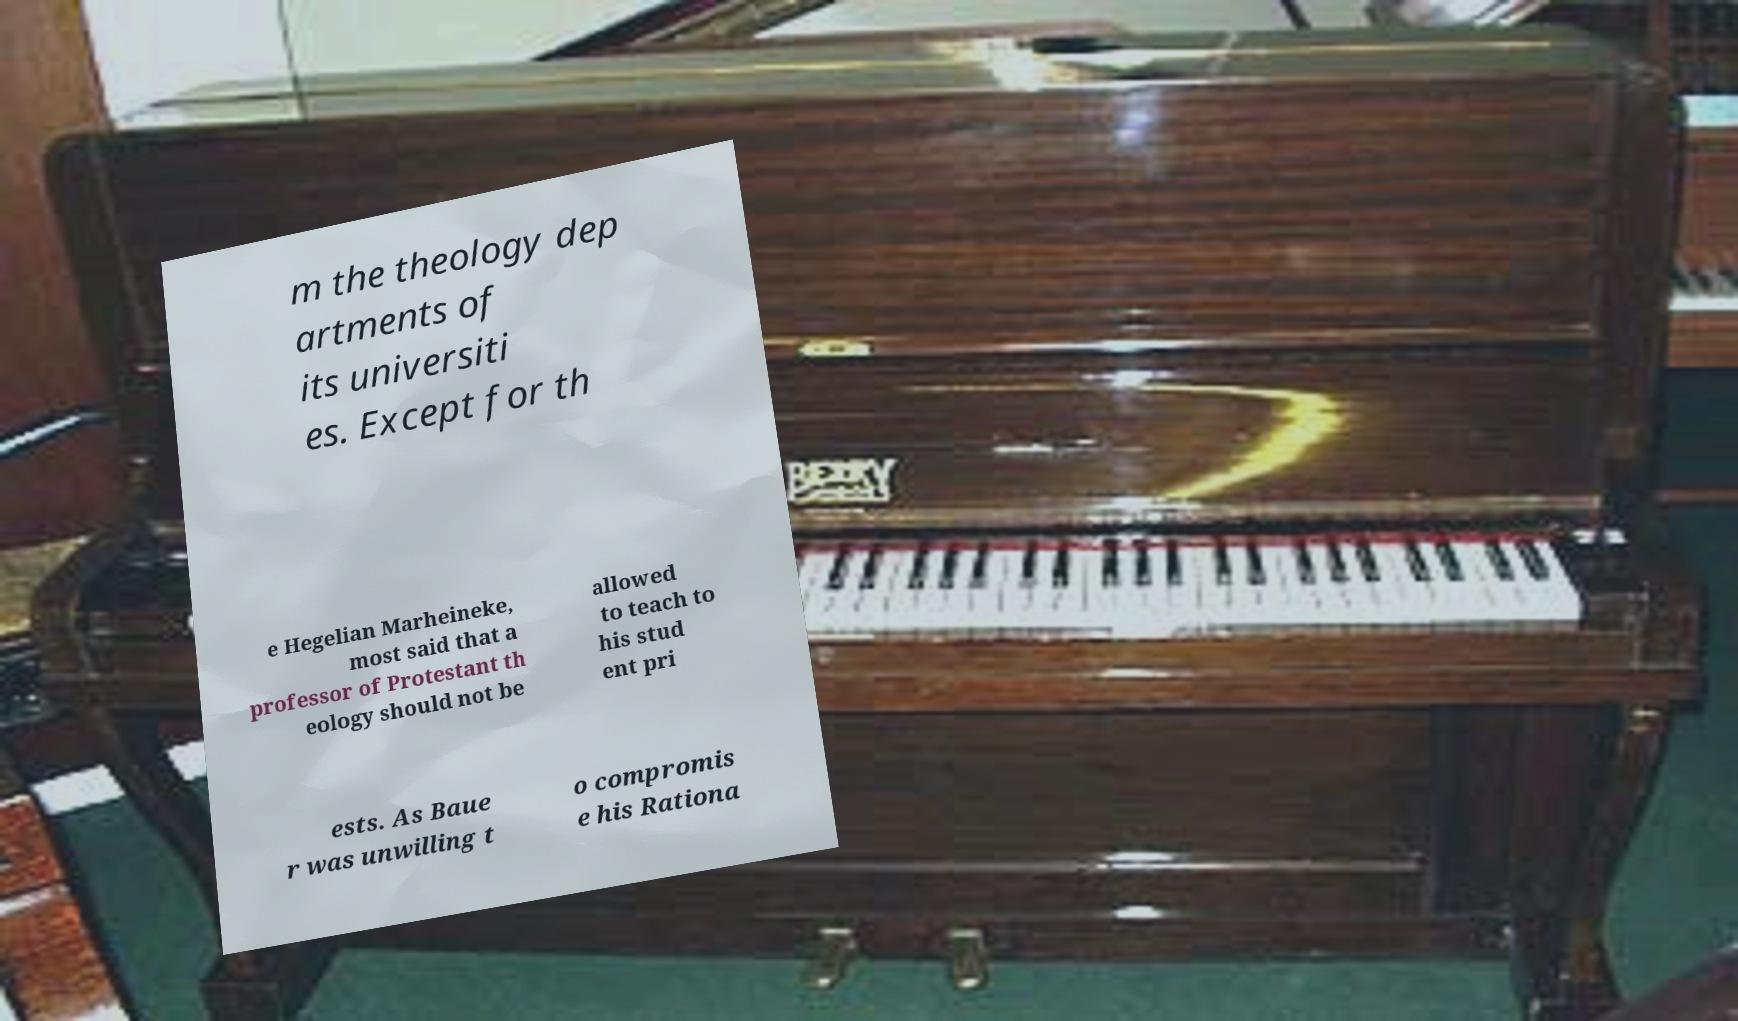Please identify and transcribe the text found in this image. m the theology dep artments of its universiti es. Except for th e Hegelian Marheineke, most said that a professor of Protestant th eology should not be allowed to teach to his stud ent pri ests. As Baue r was unwilling t o compromis e his Rationa 